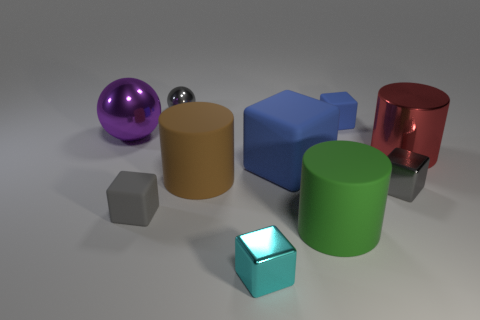There is a red shiny thing right of the purple metal sphere; what is its shape?
Ensure brevity in your answer.  Cylinder. What number of purple shiny things are there?
Provide a short and direct response. 1. Are the red object and the cyan cube made of the same material?
Provide a succinct answer. Yes. Are there more metallic objects that are right of the large red shiny cylinder than gray matte objects?
Offer a very short reply. No. How many things are either green cylinders or tiny gray objects in front of the tiny blue object?
Offer a terse response. 3. Is the number of brown things that are in front of the gray metallic cube greater than the number of large red things to the left of the small blue rubber cube?
Provide a short and direct response. No. What is the small gray thing on the right side of the gray shiny sphere that is right of the gray block that is left of the cyan metal cube made of?
Offer a terse response. Metal. What is the shape of the gray object that is made of the same material as the green cylinder?
Provide a succinct answer. Cube. There is a matte thing to the left of the small metallic sphere; are there any blue objects that are in front of it?
Your answer should be compact. No. How big is the purple metal object?
Your answer should be compact. Large. 